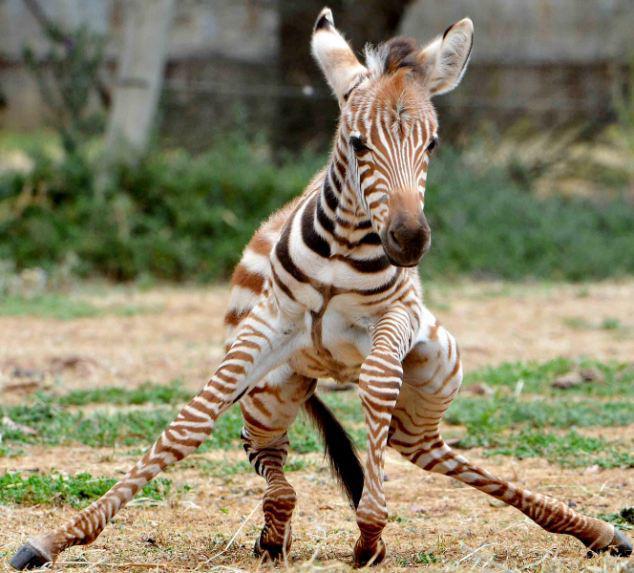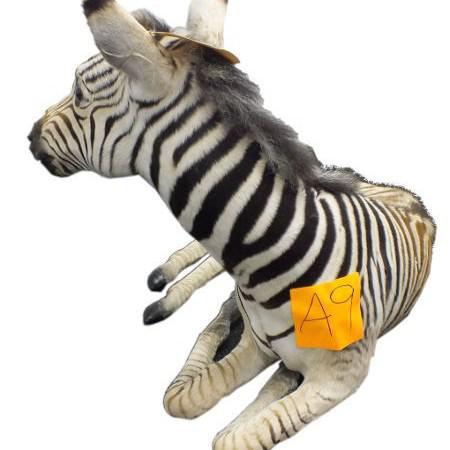The first image is the image on the left, the second image is the image on the right. Evaluate the accuracy of this statement regarding the images: "Each image shows a zebra resting in the grass, and one image actually shows the zebra in a position with front knees both bent.". Is it true? Answer yes or no. No. The first image is the image on the left, the second image is the image on the right. Given the left and right images, does the statement "The zebra in the image on the left is standing in a field." hold true? Answer yes or no. Yes. 